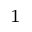<formula> <loc_0><loc_0><loc_500><loc_500>^ { 1 }</formula> 